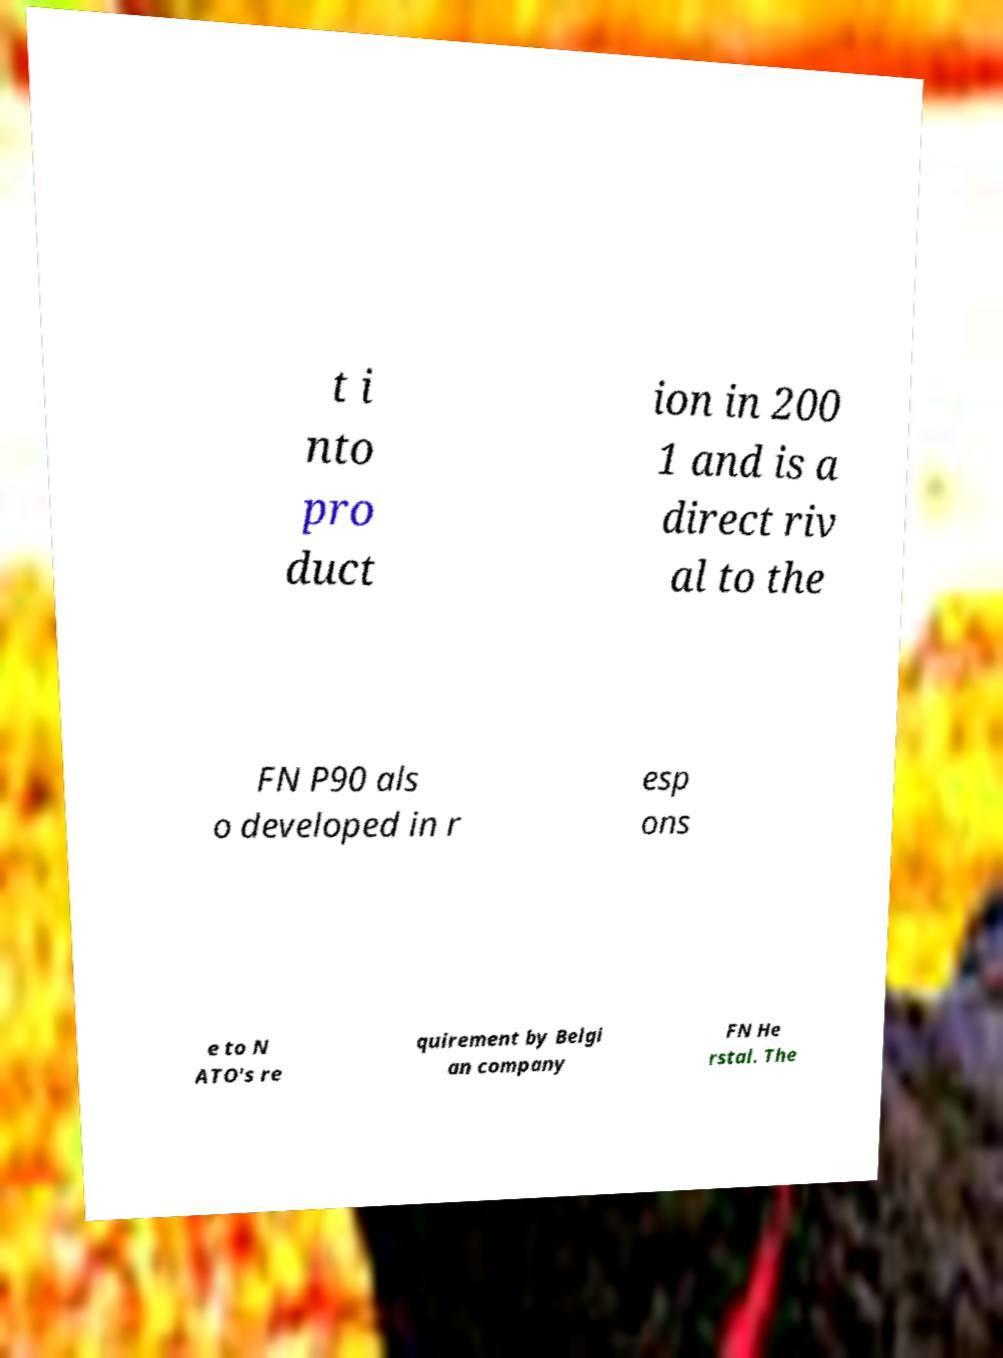Could you assist in decoding the text presented in this image and type it out clearly? t i nto pro duct ion in 200 1 and is a direct riv al to the FN P90 als o developed in r esp ons e to N ATO's re quirement by Belgi an company FN He rstal. The 